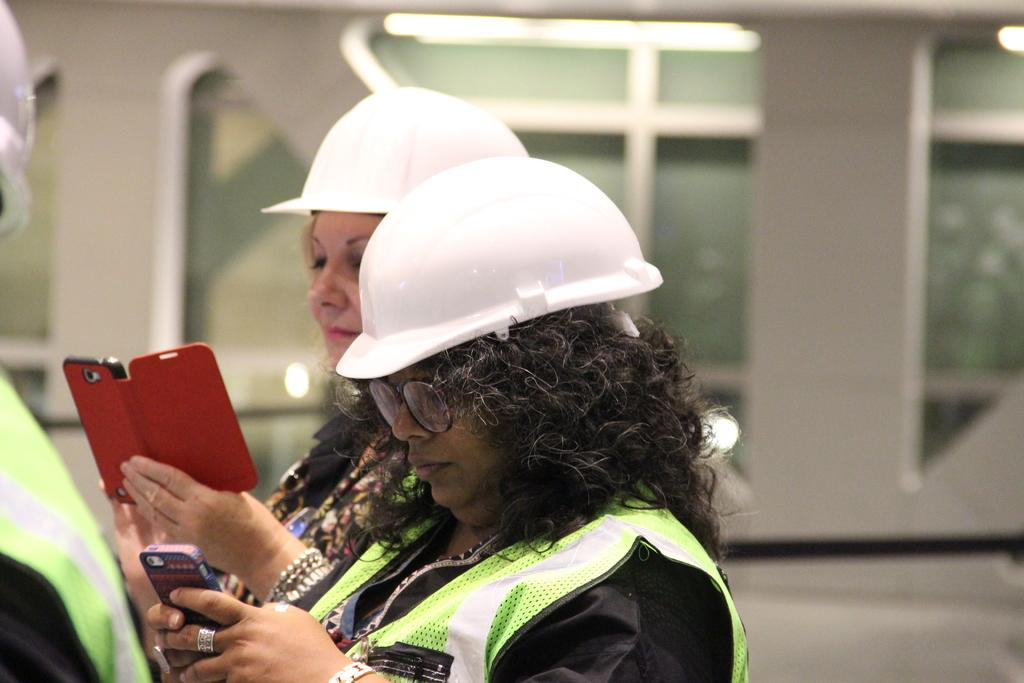How many people are in the image? There are two women in the image. What are the women holding in their hands? The women are holding mobile phones in their hands. What type of headgear are the women wearing? The women are wearing white helmets. What type of worm can be seen crawling on the helmets in the image? There are no worms present in the image; the women are wearing white helmets. What type of wool is being used to knit the helmets in the image? The helmets in the image are not made of wool; they are white helmets. 